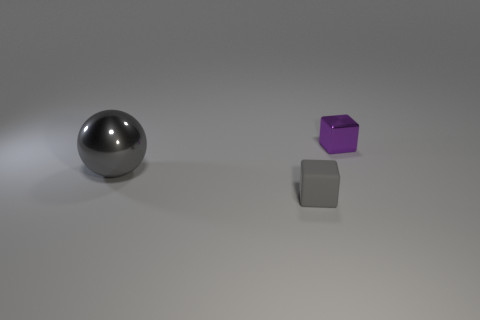Does the rubber thing have the same color as the metal block?
Ensure brevity in your answer.  No. Is the material of the small purple cube the same as the block in front of the big gray shiny object?
Provide a succinct answer. No. What color is the metal object in front of the small purple metal thing on the right side of the large ball?
Give a very brief answer. Gray. Are there any large balls of the same color as the small rubber object?
Ensure brevity in your answer.  Yes. What size is the gray object that is behind the small object that is on the left side of the metal thing that is to the right of the rubber block?
Your answer should be compact. Large. Do the purple thing and the small object in front of the tiny metal thing have the same shape?
Your response must be concise. Yes. What number of other objects are the same size as the gray ball?
Give a very brief answer. 0. How big is the metal object right of the small gray matte cube?
Make the answer very short. Small. What number of big gray objects are the same material as the tiny purple block?
Your response must be concise. 1. Is the shape of the tiny thing behind the small gray matte thing the same as  the big gray metallic object?
Your response must be concise. No. 